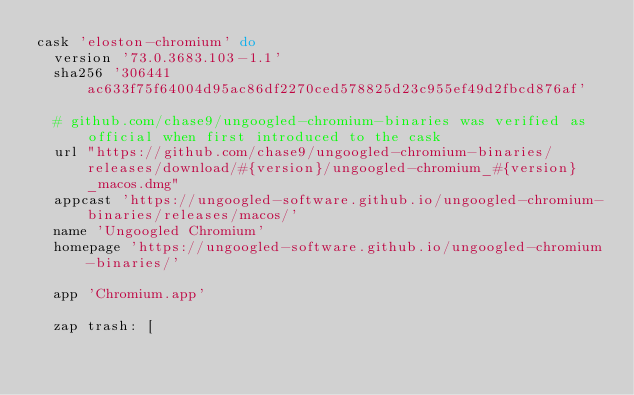<code> <loc_0><loc_0><loc_500><loc_500><_Ruby_>cask 'eloston-chromium' do
  version '73.0.3683.103-1.1'
  sha256 '306441ac633f75f64004d95ac86df2270ced578825d23c955ef49d2fbcd876af'

  # github.com/chase9/ungoogled-chromium-binaries was verified as official when first introduced to the cask
  url "https://github.com/chase9/ungoogled-chromium-binaries/releases/download/#{version}/ungoogled-chromium_#{version}_macos.dmg"
  appcast 'https://ungoogled-software.github.io/ungoogled-chromium-binaries/releases/macos/'
  name 'Ungoogled Chromium'
  homepage 'https://ungoogled-software.github.io/ungoogled-chromium-binaries/'

  app 'Chromium.app'

  zap trash: [</code> 